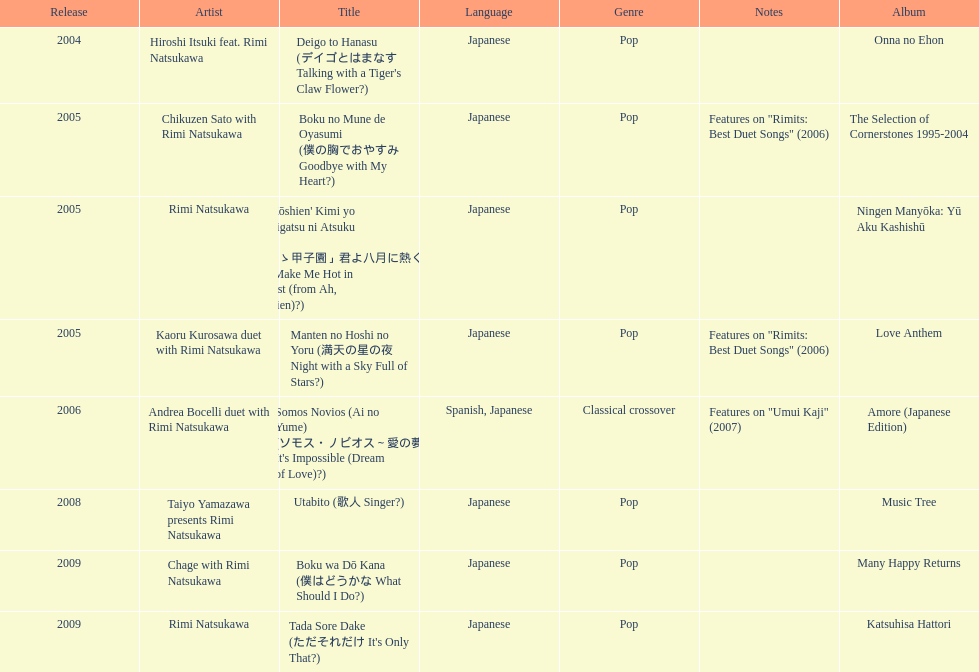What are the names of each album by rimi natsukawa? Onna no Ehon, The Selection of Cornerstones 1995-2004, Ningen Manyōka: Yū Aku Kashishū, Love Anthem, Amore (Japanese Edition), Music Tree, Many Happy Returns, Katsuhisa Hattori. And when were the albums released? 2004, 2005, 2005, 2005, 2006, 2008, 2009, 2009. Was onna no ehon or music tree released most recently? Music Tree. 